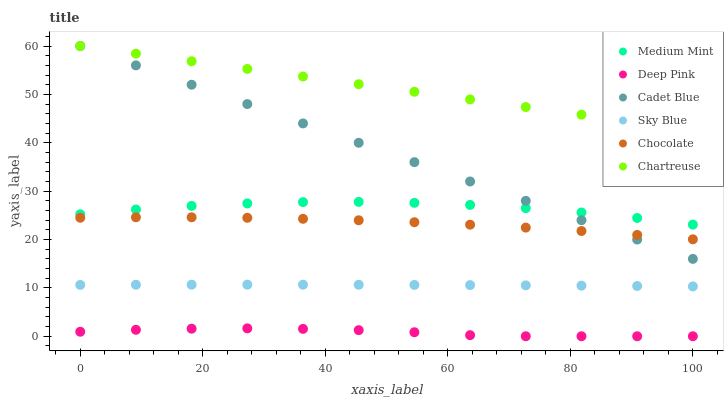Does Deep Pink have the minimum area under the curve?
Answer yes or no. Yes. Does Chartreuse have the maximum area under the curve?
Answer yes or no. Yes. Does Chocolate have the minimum area under the curve?
Answer yes or no. No. Does Chocolate have the maximum area under the curve?
Answer yes or no. No. Is Cadet Blue the smoothest?
Answer yes or no. Yes. Is Medium Mint the roughest?
Answer yes or no. Yes. Is Deep Pink the smoothest?
Answer yes or no. No. Is Deep Pink the roughest?
Answer yes or no. No. Does Deep Pink have the lowest value?
Answer yes or no. Yes. Does Chocolate have the lowest value?
Answer yes or no. No. Does Cadet Blue have the highest value?
Answer yes or no. Yes. Does Chocolate have the highest value?
Answer yes or no. No. Is Chocolate less than Medium Mint?
Answer yes or no. Yes. Is Medium Mint greater than Sky Blue?
Answer yes or no. Yes. Does Chartreuse intersect Cadet Blue?
Answer yes or no. Yes. Is Chartreuse less than Cadet Blue?
Answer yes or no. No. Is Chartreuse greater than Cadet Blue?
Answer yes or no. No. Does Chocolate intersect Medium Mint?
Answer yes or no. No. 